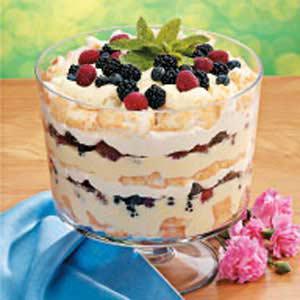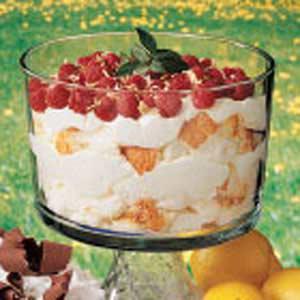The first image is the image on the left, the second image is the image on the right. Examine the images to the left and right. Is the description "There are lemon slices on top of a trifle in one of the images." accurate? Answer yes or no. No. The first image is the image on the left, the second image is the image on the right. Considering the images on both sides, is "At least one image shows individual servings of layered dessert in non-footed glasses garnished with raspberries." valid? Answer yes or no. No. 